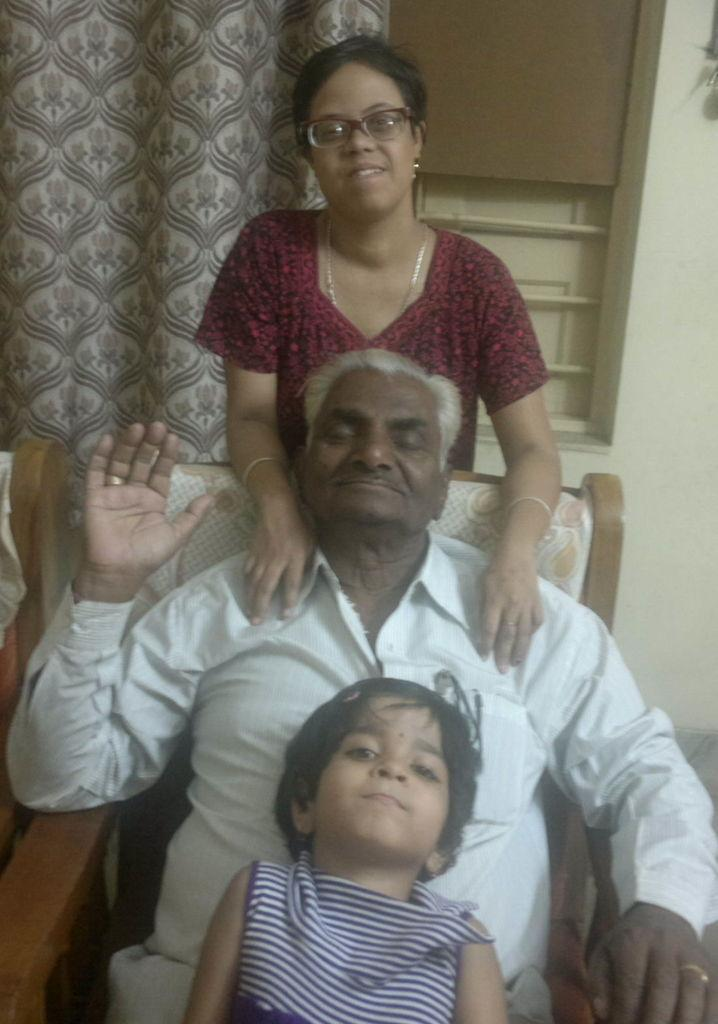What is the man doing in the image? The man is sitting on a chair in the image. Who else is present in the image besides the man? There is a child and a woman in the image. What can be seen outside the room in the image? There is a window visible in the image, which shows the outside environment. What is the purpose of the curtain in the image? The curtain is associated with the window, and it might be used for privacy or to control the amount of light entering the room. What type of watch is the child wearing in the image? There is no watch visible on the child in the image. What is the child writing in the image? There is no writing activity depicted in the image; the child is simply present with the man and woman. 